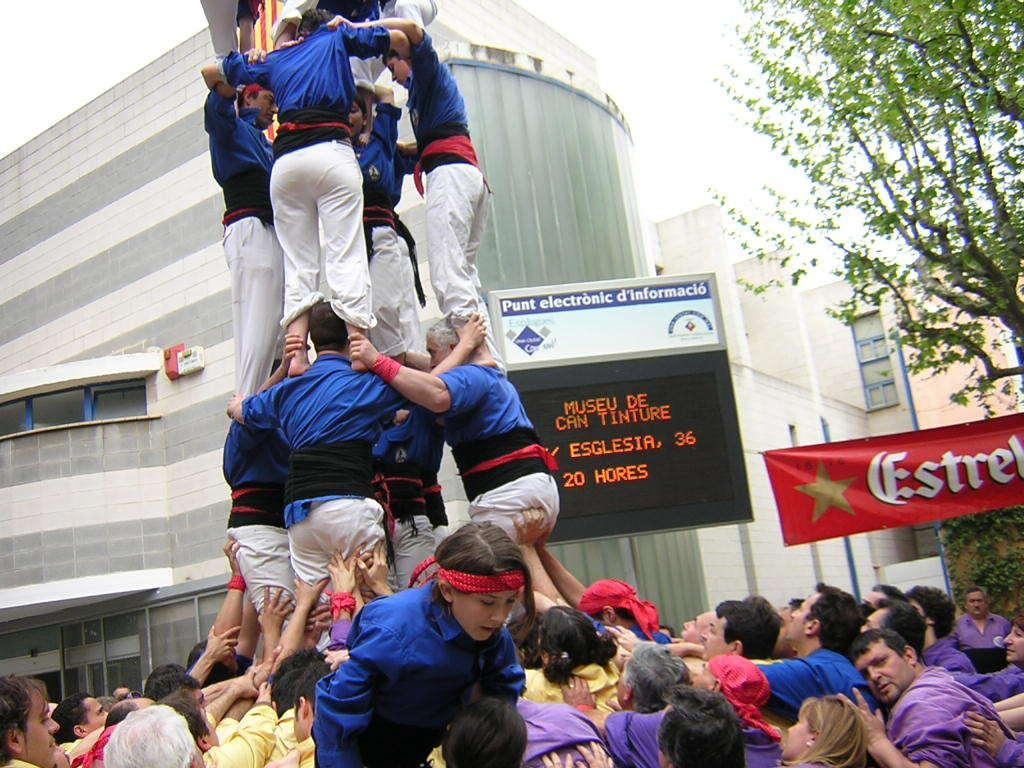Please provide a concise description of this image. In this image, at the bottom there is a woman, there are many people. In the middle there are people standing. In the background there are posters, board, text, screen, buildings, tree, sky. 